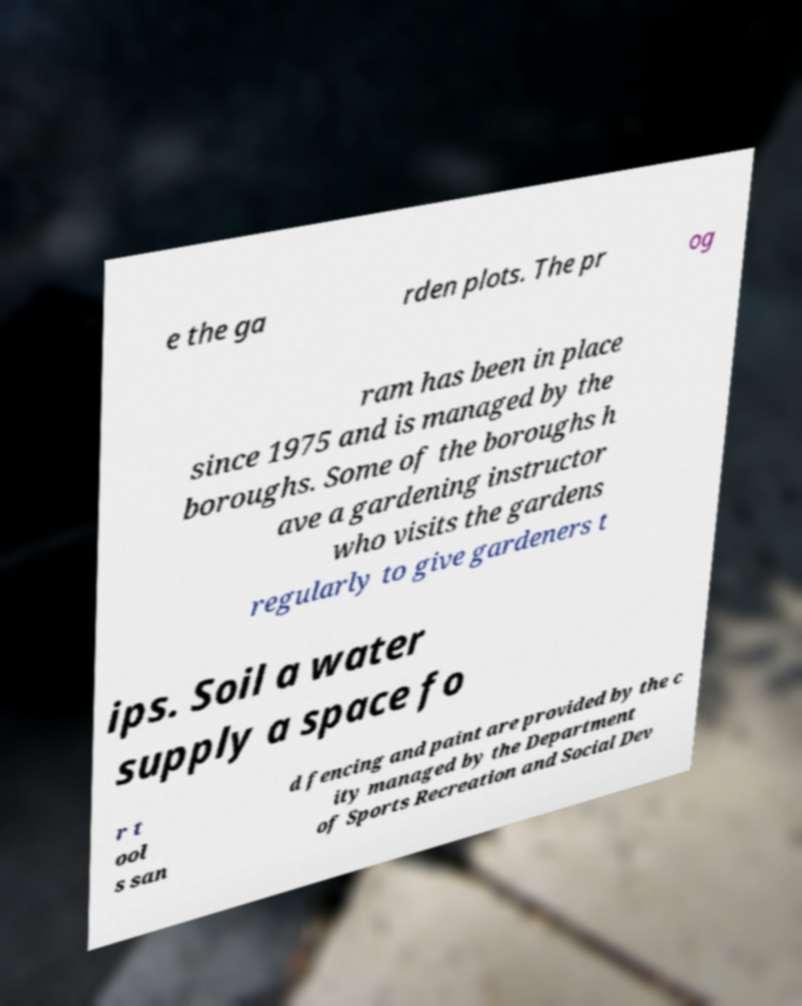Could you assist in decoding the text presented in this image and type it out clearly? e the ga rden plots. The pr og ram has been in place since 1975 and is managed by the boroughs. Some of the boroughs h ave a gardening instructor who visits the gardens regularly to give gardeners t ips. Soil a water supply a space fo r t ool s san d fencing and paint are provided by the c ity managed by the Department of Sports Recreation and Social Dev 